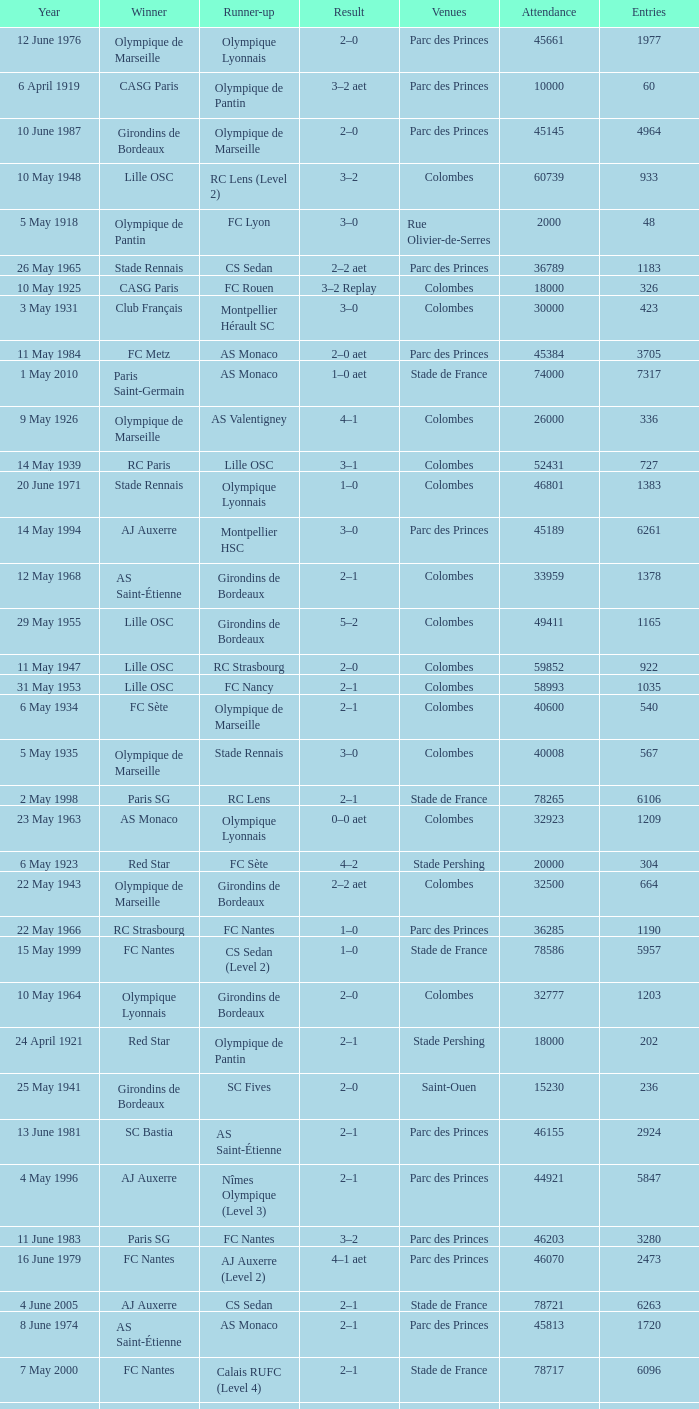How many games had red star as the runner up? 1.0. 